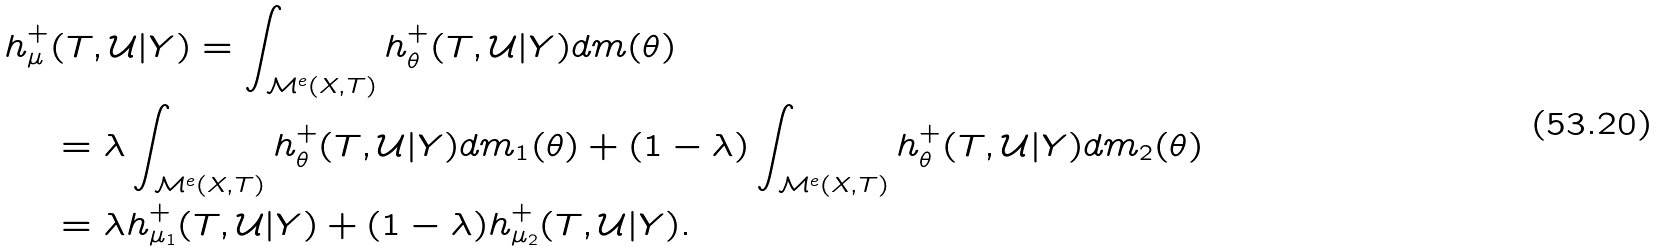<formula> <loc_0><loc_0><loc_500><loc_500>h ^ { + } _ { \mu } & ( T , \mathcal { U } | Y ) = \int _ { \mathcal { M } ^ { e } ( X , T ) } h _ { \theta } ^ { + } ( T , \mathcal { U } | Y ) d m ( \theta ) \\ & = \lambda \int _ { \mathcal { M } ^ { e } ( X , T ) } h _ { \theta } ^ { + } ( T , \mathcal { U } | Y ) d m _ { 1 } ( \theta ) + ( 1 - \lambda ) \int _ { \mathcal { M } ^ { e } ( X , T ) } h _ { \theta } ^ { + } ( T , \mathcal { U } | Y ) d m _ { 2 } ( \theta ) \\ & = \lambda h ^ { + } _ { \mu _ { 1 } } ( T , \mathcal { U } | Y ) + ( 1 - \lambda ) h ^ { + } _ { \mu _ { 2 } } ( T , \mathcal { U } | Y ) .</formula> 